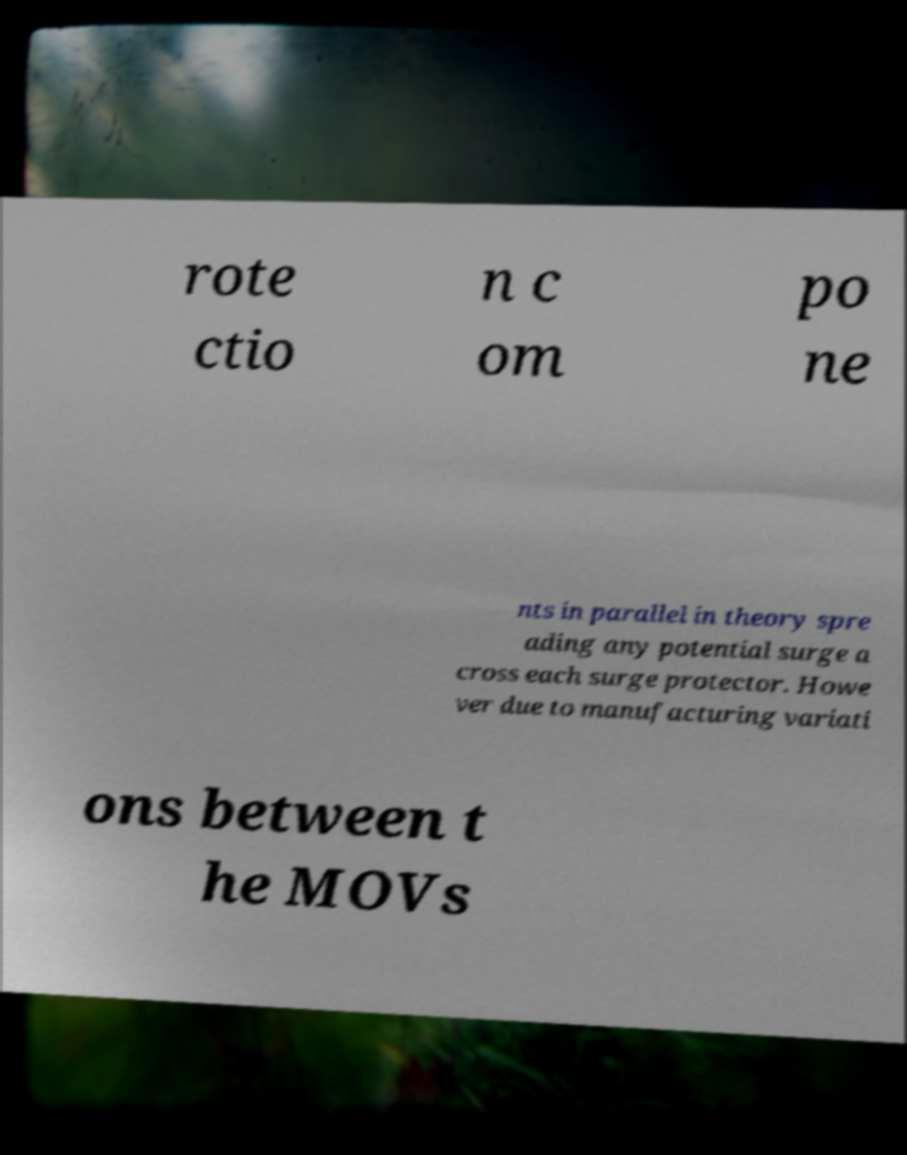Please identify and transcribe the text found in this image. rote ctio n c om po ne nts in parallel in theory spre ading any potential surge a cross each surge protector. Howe ver due to manufacturing variati ons between t he MOVs 